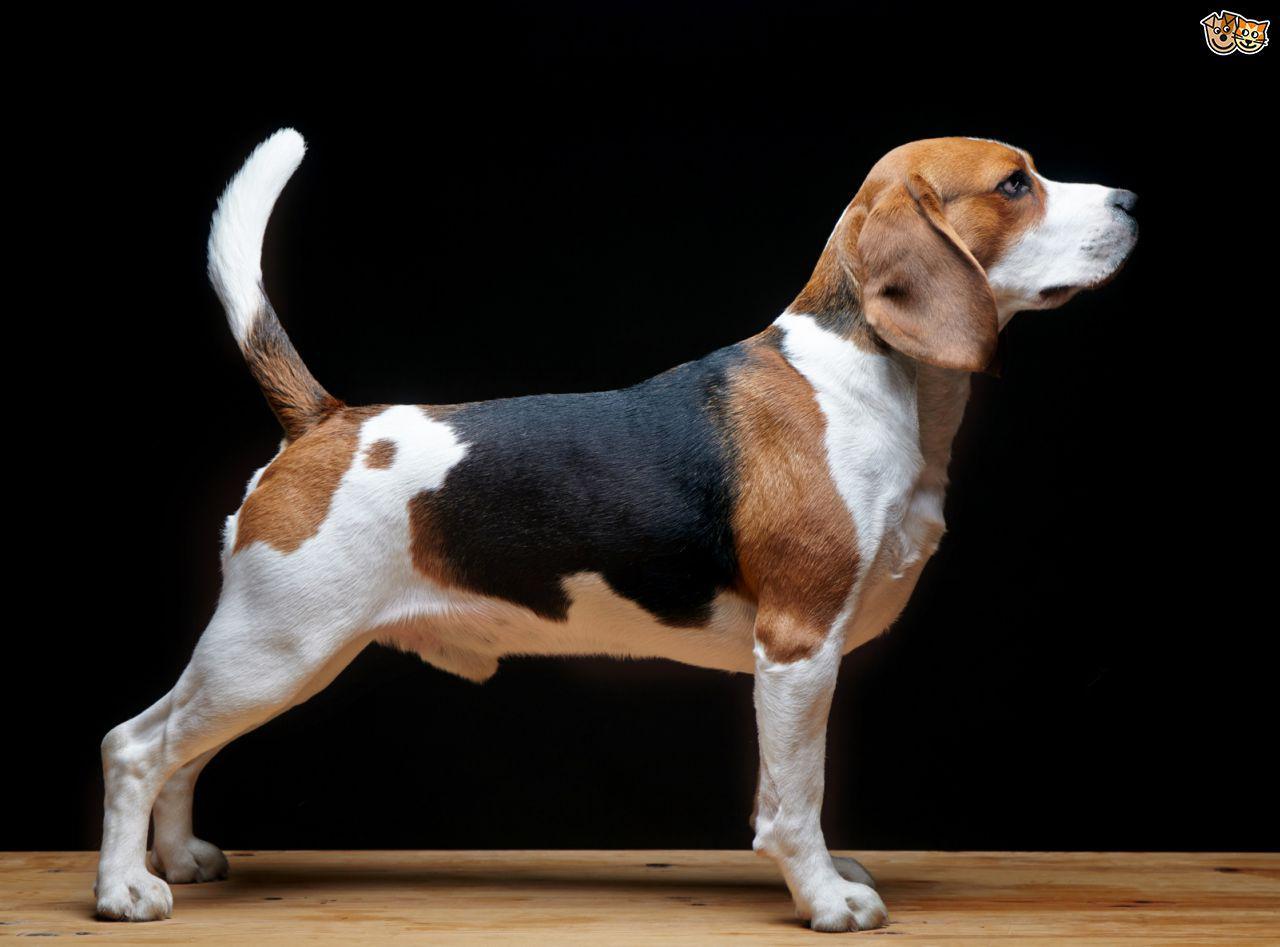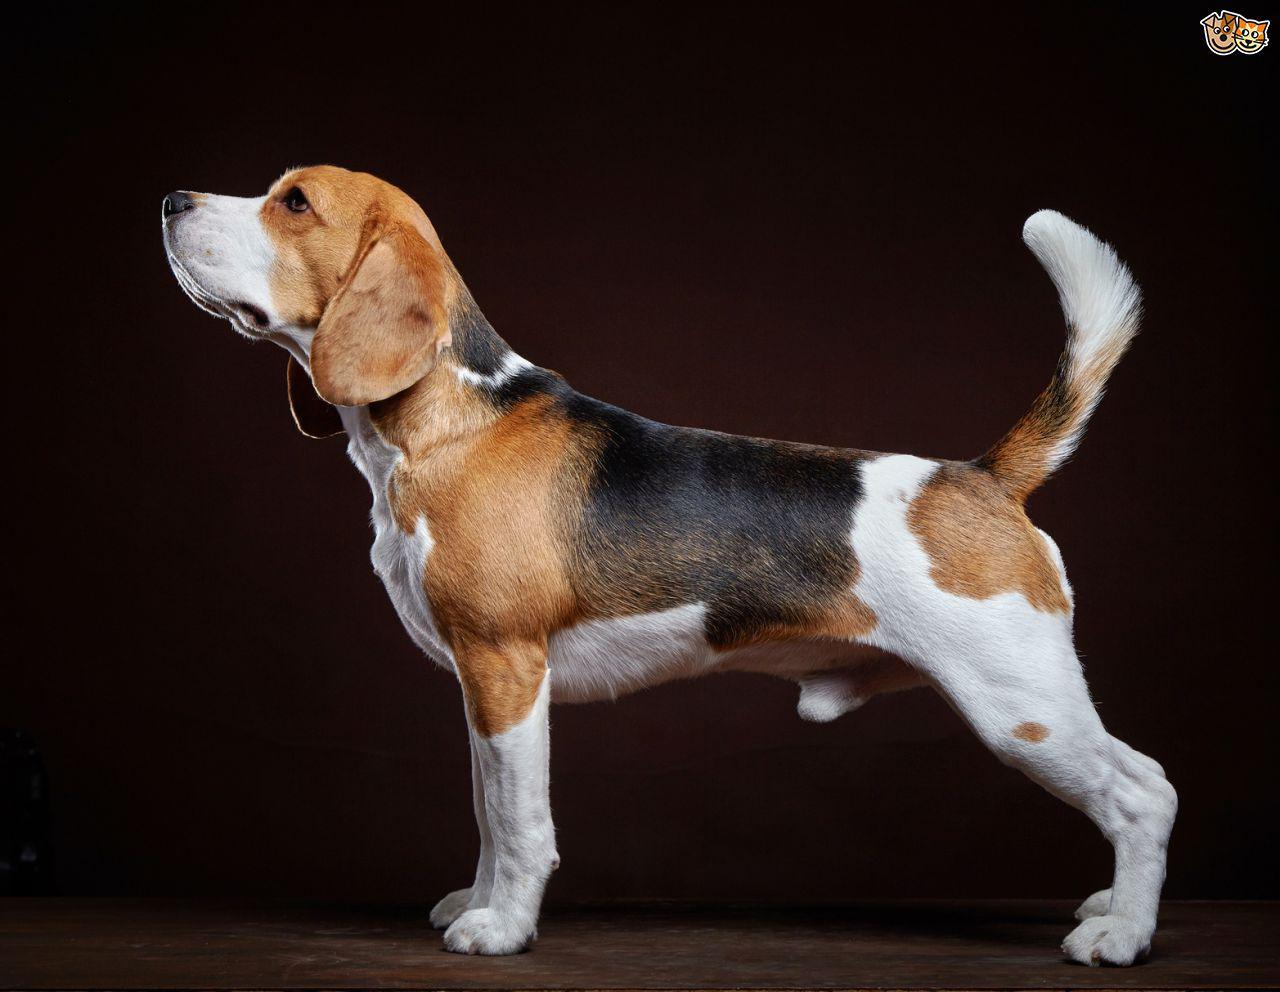The first image is the image on the left, the second image is the image on the right. For the images shown, is this caption "At least one dog is sitting." true? Answer yes or no. No. 